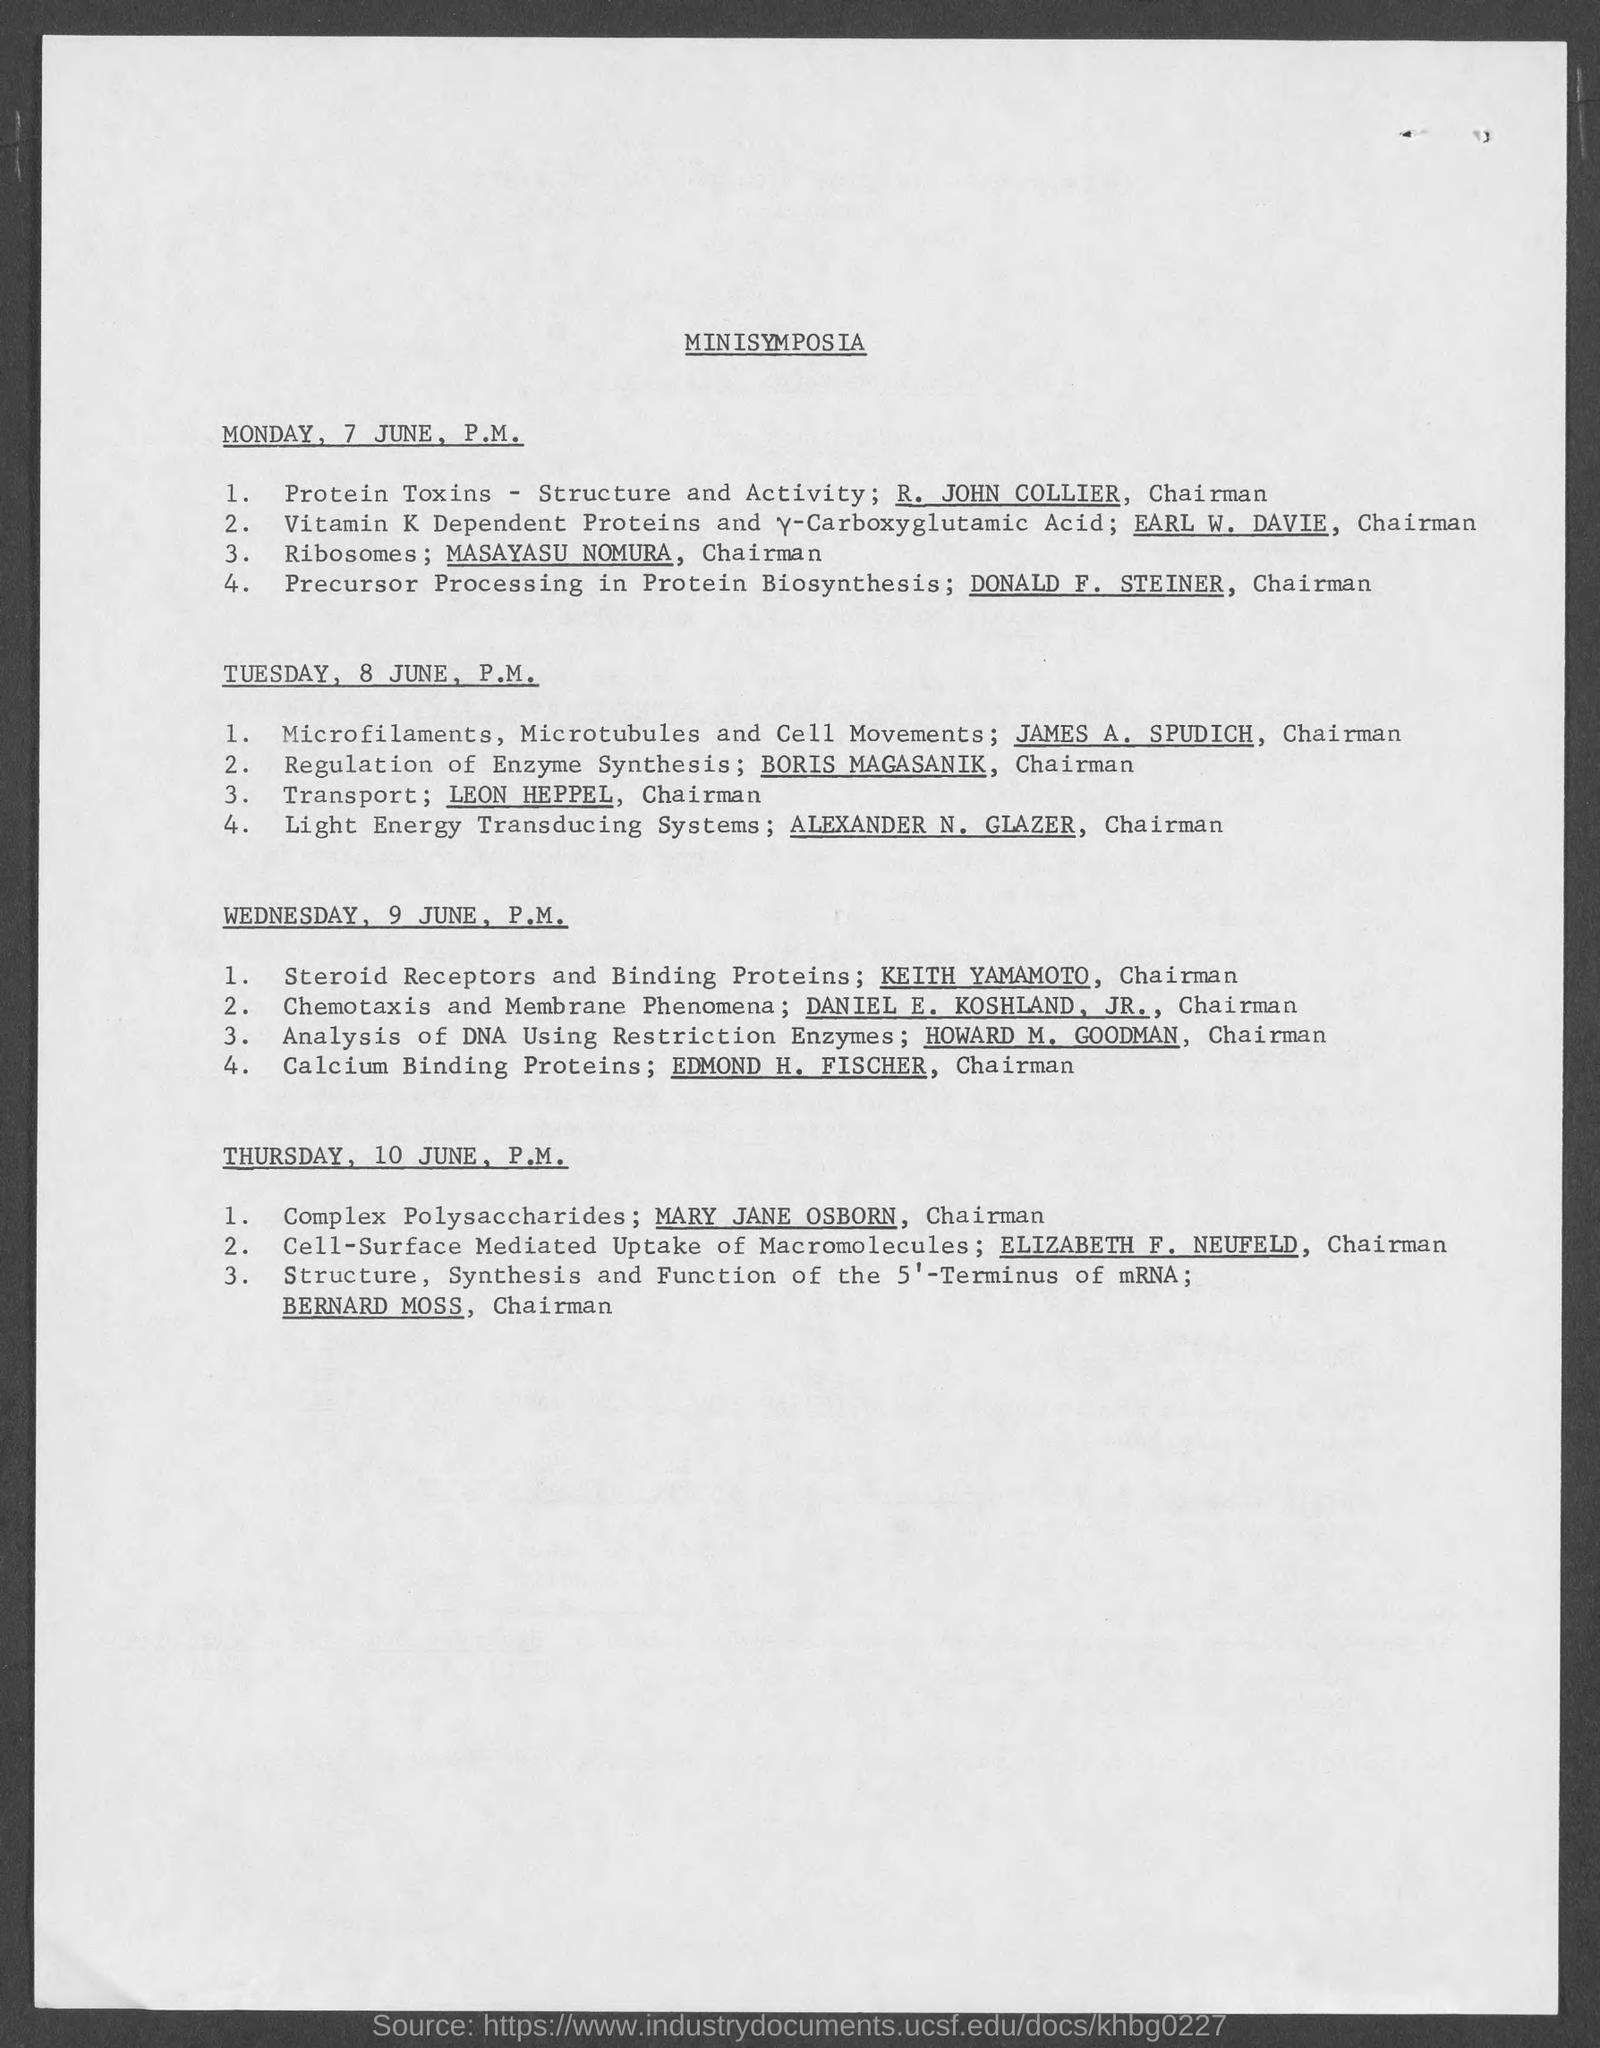What is the Title of the document?
Provide a succinct answer. Minisymposia. Who does the session for calcium binding proteins?
Provide a short and direct response. Edmond H. Fischer. 